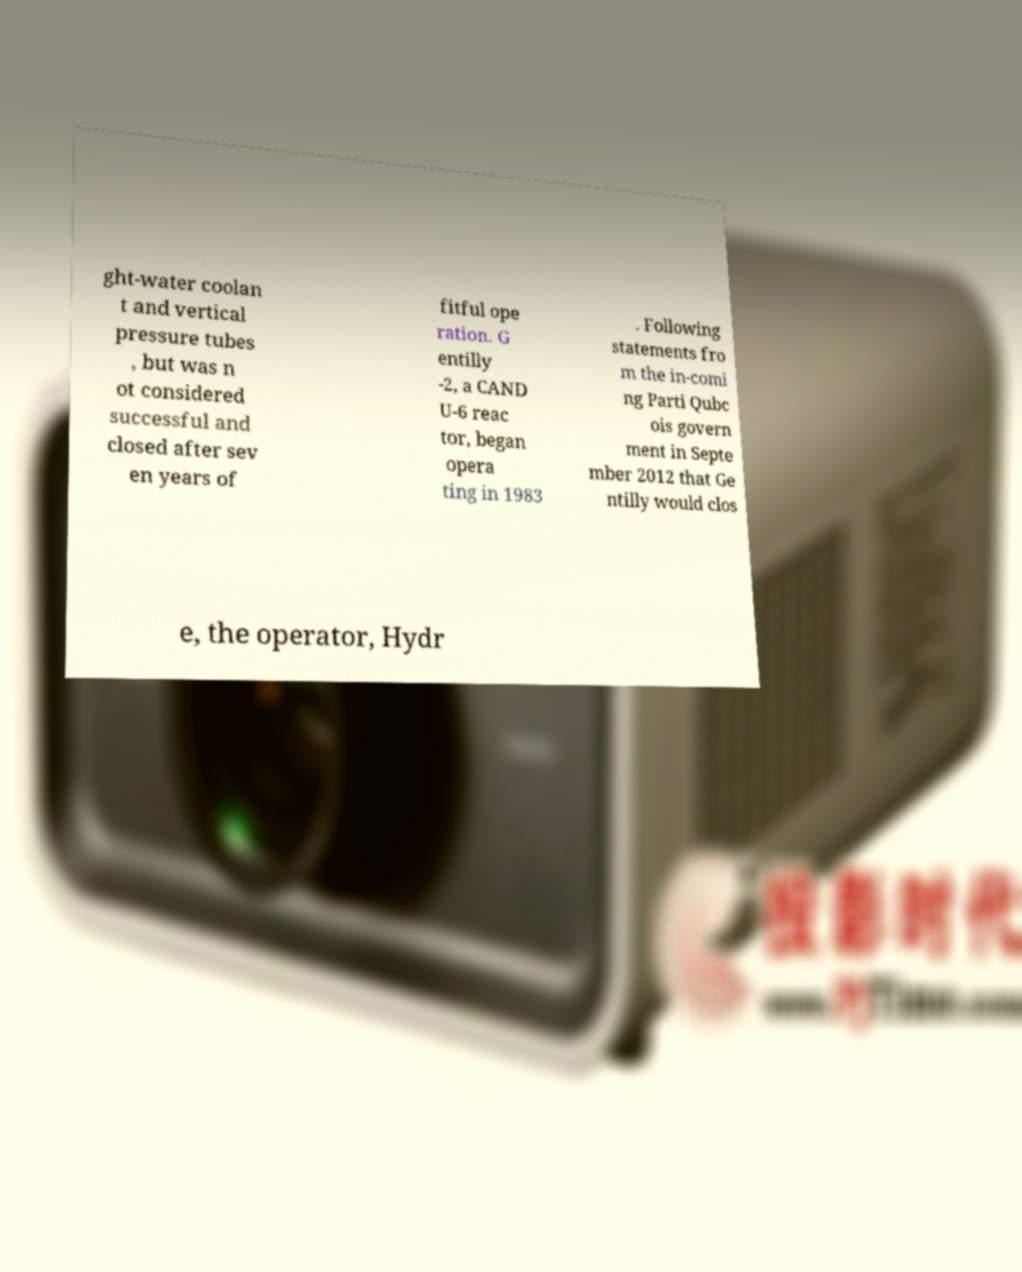Please identify and transcribe the text found in this image. ght-water coolan t and vertical pressure tubes , but was n ot considered successful and closed after sev en years of fitful ope ration. G entilly -2, a CAND U-6 reac tor, began opera ting in 1983 . Following statements fro m the in-comi ng Parti Qubc ois govern ment in Septe mber 2012 that Ge ntilly would clos e, the operator, Hydr 